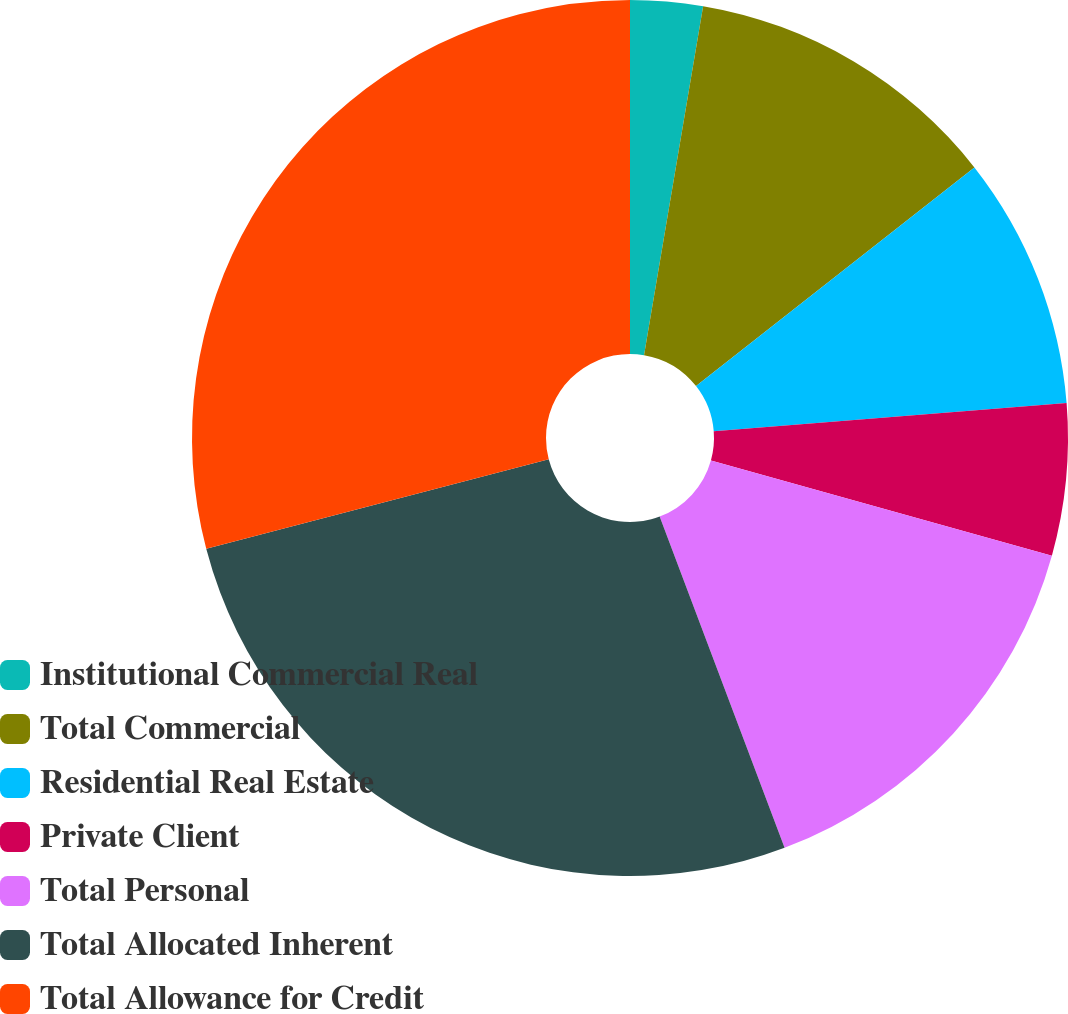Convert chart to OTSL. <chart><loc_0><loc_0><loc_500><loc_500><pie_chart><fcel>Institutional Commercial Real<fcel>Total Commercial<fcel>Residential Real Estate<fcel>Private Client<fcel>Total Personal<fcel>Total Allocated Inherent<fcel>Total Allowance for Credit<nl><fcel>2.67%<fcel>11.73%<fcel>9.33%<fcel>5.6%<fcel>14.93%<fcel>26.67%<fcel>29.07%<nl></chart> 